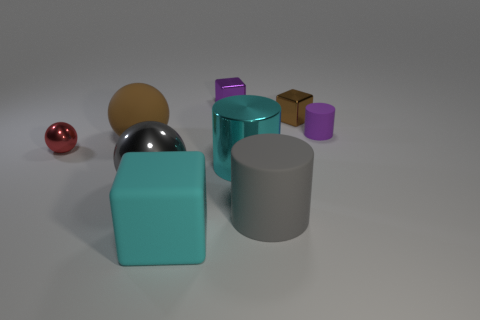There is a brown sphere that is the same size as the cyan block; what material is it?
Your response must be concise. Rubber. Is there a purple cylinder that is in front of the metal thing that is on the right side of the large rubber cylinder?
Make the answer very short. Yes. How many other things are the same color as the big block?
Your response must be concise. 1. The cyan cube has what size?
Offer a very short reply. Large. Are any shiny things visible?
Provide a short and direct response. Yes. Is the number of brown objects behind the purple cylinder greater than the number of red objects on the right side of the tiny brown object?
Your answer should be very brief. Yes. There is a object that is both in front of the cyan shiny cylinder and right of the purple metal cube; what is its material?
Ensure brevity in your answer.  Rubber. Do the tiny brown thing and the big brown matte thing have the same shape?
Offer a terse response. No. What number of large things are behind the small sphere?
Keep it short and to the point. 1. There is a shiny object that is left of the brown rubber thing; does it have the same size as the small brown shiny thing?
Provide a succinct answer. Yes. 